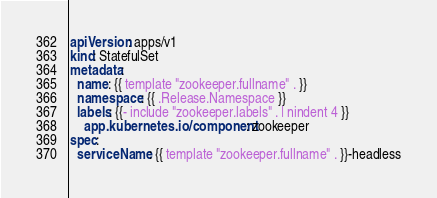<code> <loc_0><loc_0><loc_500><loc_500><_YAML_>apiVersion: apps/v1
kind: StatefulSet
metadata:
  name: {{ template "zookeeper.fullname" . }}
  namespace: {{ .Release.Namespace }}
  labels: {{- include "zookeeper.labels" . | nindent 4 }}
    app.kubernetes.io/component: zookeeper
spec:
  serviceName: {{ template "zookeeper.fullname" . }}-headless</code> 